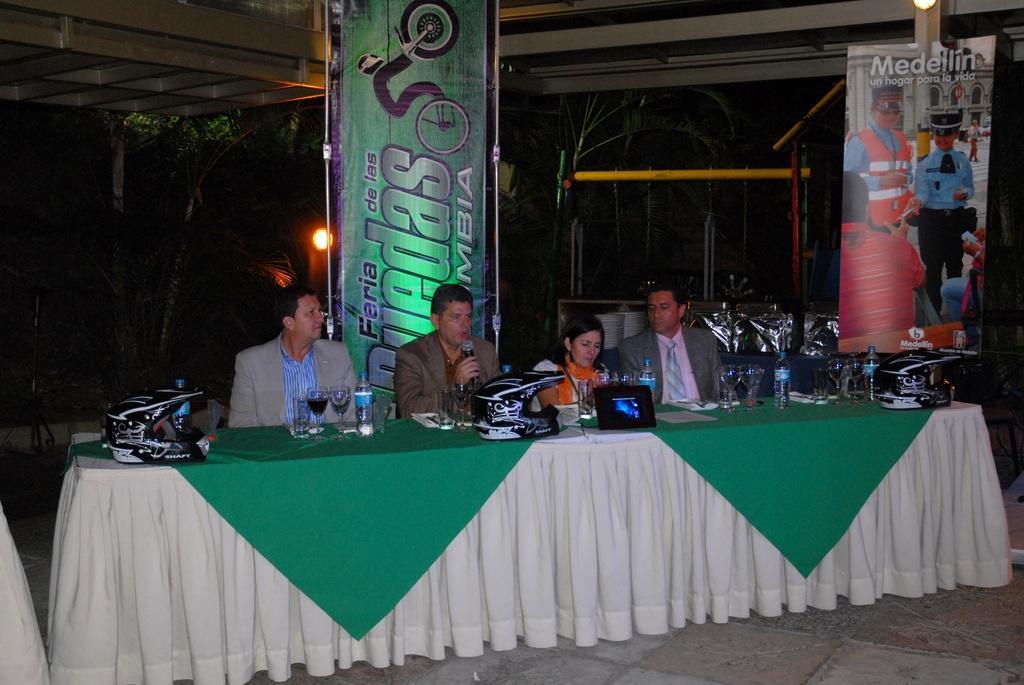Can you describe this image briefly? This picture is clicked inside. In the foreground there is a table on the top of which we can see the helmets, water bottles, glasses of water, glass of drink and some other items are placed and we can see the group of persons sitting on the chairs. In the background we can see the metal rods, roof, light, trees, banners on which we can see the text and some pictures and there are some other items in the background. 